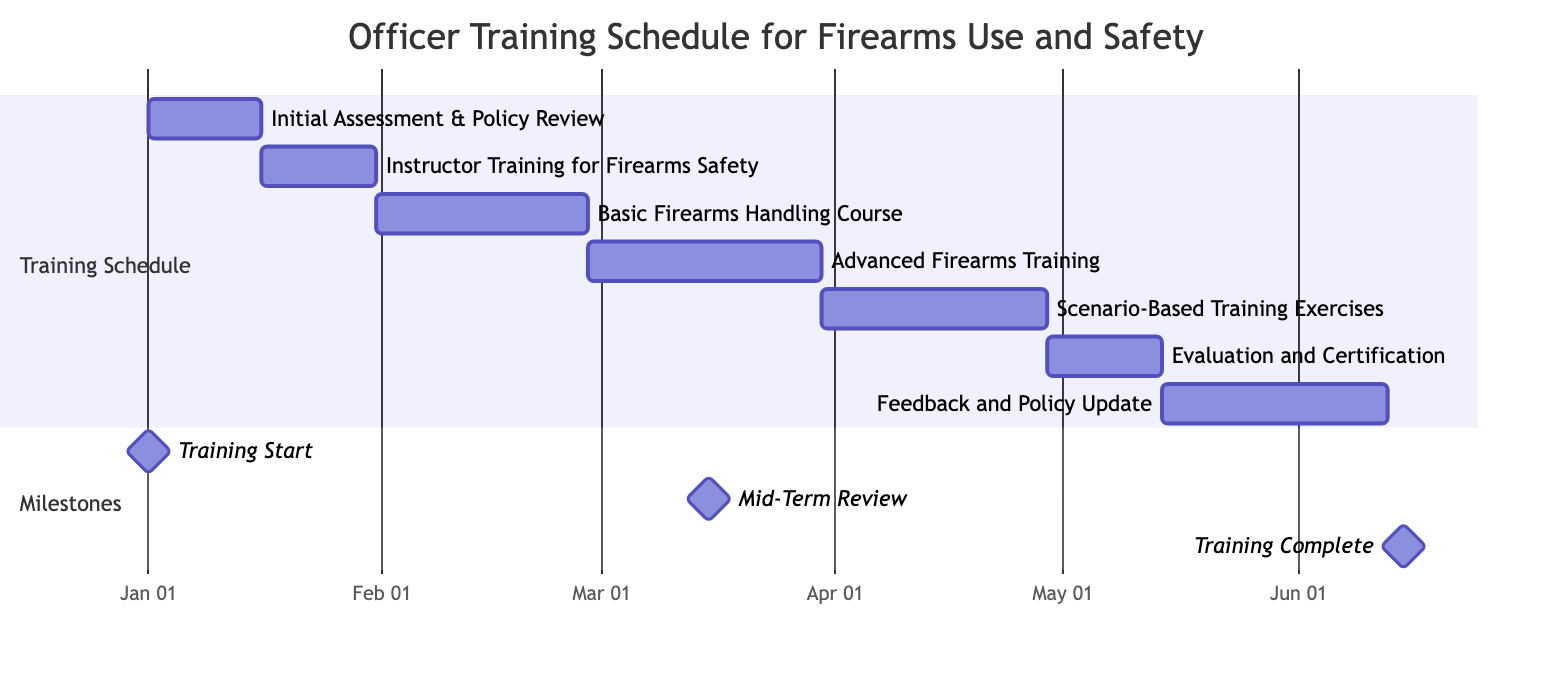what is the duration of the Basic Firearms Handling Course? The duration of the Basic Firearms Handling Course is provided in the Gantt chart as 28 days.
Answer: 28 days when does the Evaluation and Certification phase start? The Evaluation and Certification phase starts immediately after Scenario-Based Training Exercises, which ends on May 15, 2024. Thus, it starts on May 1, 2024.
Answer: May 1, 2024 what is the start date of the Instructor Training for Firearms Safety? The start date for the Instructor Training for Firearms Safety is listed directly in the Gantt chart as January 16, 2024.
Answer: January 16, 2024 how many days are allocated for Feedback and Policy Update? The duration of Feedback and Policy Update is shown in the Gantt chart as 30 days, which means this is the time allocated for this task.
Answer: 30 days what milestone is scheduled for March 15, 2024? The Gantt chart indicates that the Mid-Term Review is scheduled for March 15, 2024, as a milestone.
Answer: Mid-Term Review which task has the longest duration in this training schedule? A comparison of the durations of each task indicates that the Advanced Firearms Training has the longest duration of 31 days.
Answer: Advanced Firearms Training when do all training activities conclude? The last task on the Gantt chart, which is Feedback and Policy Update, concludes on June 15, 2024, marking the end of all training activities.
Answer: June 15, 2024 is the Initial Assessment & Policy Review completed before the Scenario-Based Training Exercises begin? Yes, the Initial Assessment & Policy Review is completed on January 15, 2024, which is before the Scenario-Based Training Exercises that start on April 1, 2024.
Answer: Yes how many tasks are listed in the schedule? The Gantt chart lists a total of six main training tasks, along with three milestones, providing a comprehensive view of the schedule.
Answer: Six tasks 